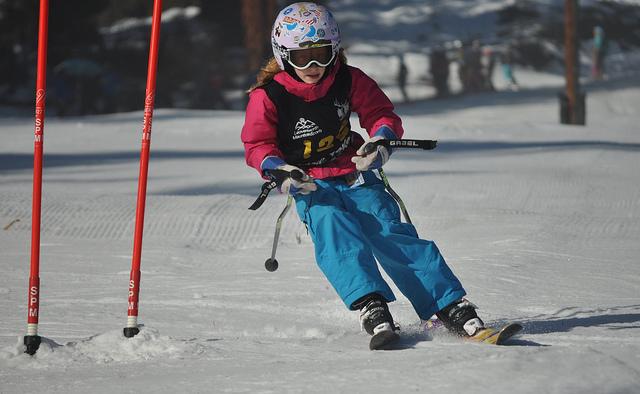What number is on the woman's chest?
Write a very short answer. 125. What color is the person's outfit?
Keep it brief. Pink and blue. Is this person moving fast?
Answer briefly. Yes. Is the girl skiing?
Concise answer only. Yes. Is it sunny?
Answer briefly. Yes. 